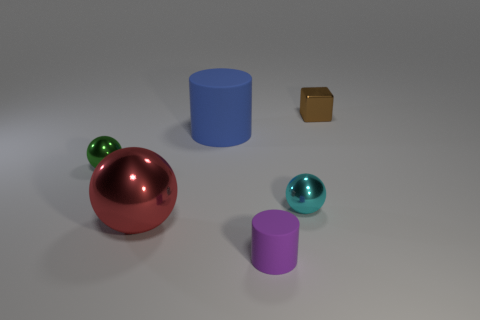There is a matte cylinder that is the same size as the red shiny thing; what color is it?
Provide a short and direct response. Blue. Are there fewer blue matte cylinders behind the big blue matte thing than purple rubber things behind the small matte thing?
Give a very brief answer. No. What number of small objects are left of the large metallic ball that is left of the small ball to the right of the large blue cylinder?
Offer a very short reply. 1. There is another blue object that is the same shape as the small matte object; what size is it?
Provide a short and direct response. Large. Are there fewer green objects in front of the red metal object than small brown cubes?
Your response must be concise. Yes. Is the brown object the same shape as the cyan metal object?
Ensure brevity in your answer.  No. What is the color of the other rubber thing that is the same shape as the tiny purple matte object?
Make the answer very short. Blue. How many small matte things have the same color as the large matte cylinder?
Your response must be concise. 0. How many objects are either cylinders that are behind the purple cylinder or large cylinders?
Make the answer very short. 1. There is a metallic thing that is to the left of the large ball; what is its size?
Offer a very short reply. Small. 